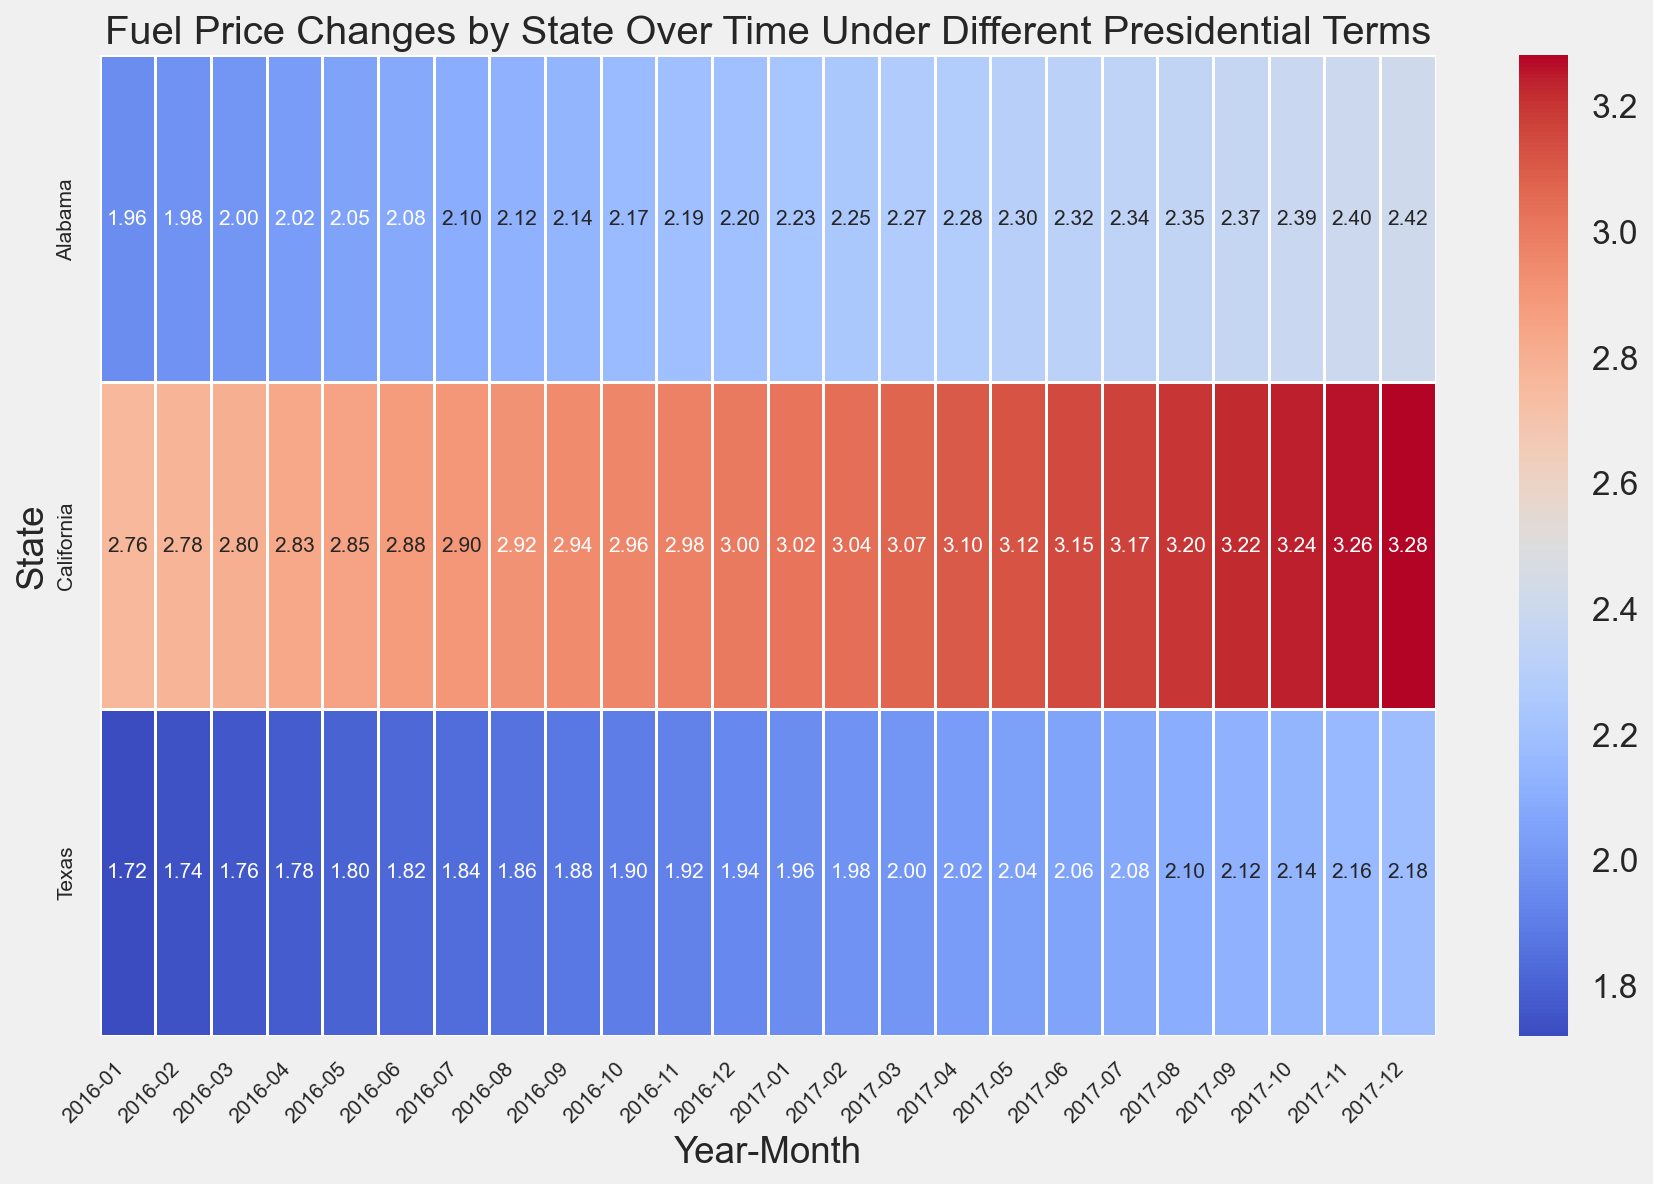What is the average fuel price in Alabama in 2016? To find the average fuel price in Alabama for 2016, add up the monthly fuel prices and divide by the number of months. The sum of the prices is 1.96 + 1.98 + 2.00 + 2.02 + 2.05 + 2.08 + 2.10 + 2.12 + 2.14 + 2.17 + 2.19 + 2.20 = 24.01. Dividing by 12 gives an average of 2.00
Answer: 2.00 Which state had the highest increase in fuel prices from January 2016 to December 2017? To determine the state with the highest increase in fuel prices, calculate the difference between December 2017 and January 2016 for each state. For Alabama, the difference is 2.42 - 1.96 = 0.46. For California, it is 3.28 - 2.76 = 0.52. For Texas, it is 2.18 - 1.72 = 0.46. California has the highest increase
Answer: California What is the difference in fuel prices between California and Texas in October 2017? Locate the fuel prices for both states in October 2017 within the heatmap. In California, the price is 3.24, and in Texas, it is 2.14. The difference is 3.24 - 2.14 = 1.10
Answer: 1.10 Which state had the lowest fuel price in July 2017? By examining the heatmap for July 2017, compare the fuel prices across all states. Alabama had a fuel price of 2.34, California had 3.17, and Texas had 2.08. Texas had the lowest fuel price
Answer: Texas How did fuel prices in Texas change from January 2016 to January 2017? Check the fuel price in Texas for January 2016 and January 2017. In January 2016, the price was 1.72, and in January 2017, it was 1.96. The change is calculated as 1.96 - 1.72 = 0.24
Answer: 0.24 Which state had more steady fuel prices under Trump's term? Compare the monthly price variations from January 2017 to December 2017. Alabama's range was 2.23 to 2.42 (variation of 0.19), California's range was 3.02 to 3.28 (variation of 0.26), and Texas' range was 1.96 to 2.18 (variation of 0.22). Alabama had the most steady prices with the smallest variation
Answer: Alabama What was the trend of fuel prices in California under Trump's term? To identify the trend in California, examine the prices from January 2017 to December 2017. The prices began at 3.02 and increased to 3.28, indicating a generally increasing trend.
Answer: Increasing Comparing fuel prices in Texas and Alabama, which state had higher prices in November 2017? Look at the heatmap for fuel prices in November 2017 for Texas and Alabama. Texas had a fuel price of 2.16, and Alabama had a price of 2.40. Alabama had higher prices
Answer: Alabama Are fuel prices more variable in California or Texas from 2016 to 2017? Compare the fuel price fluctuation ranges of both states. California's prices varied from 2.76 to 3.28 (range of 0.52), while Texas' prices ranged from 1.72 to 2.18 (range of 0.46). California had more variability
Answer: California 